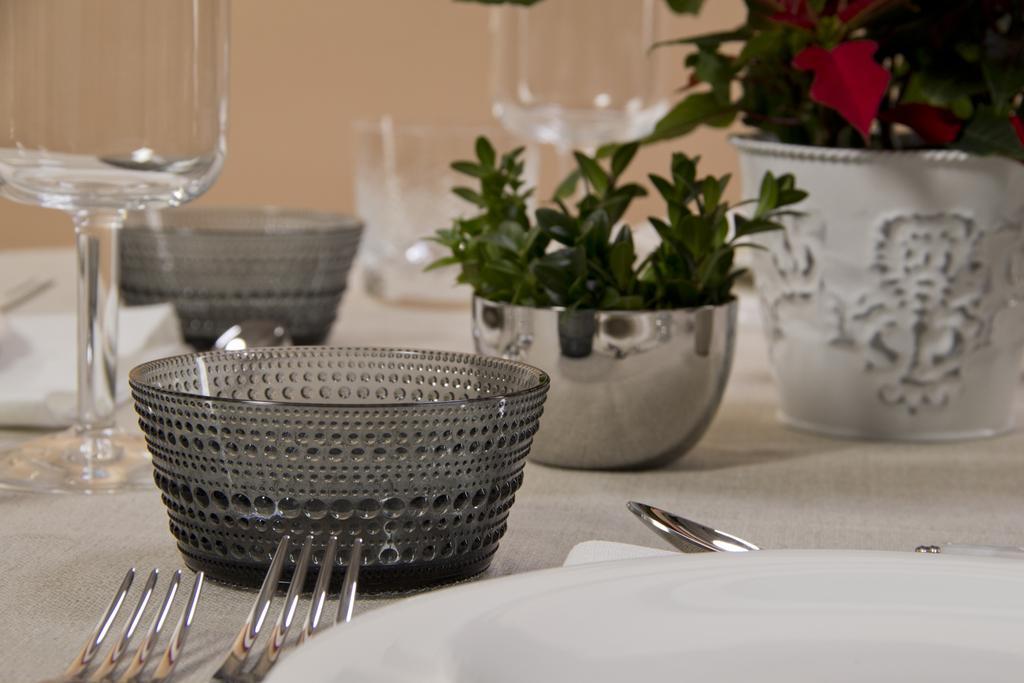Can you describe this image briefly? In this picture we can able to see plants, bowls, plates, forks, spoon and glasses. 